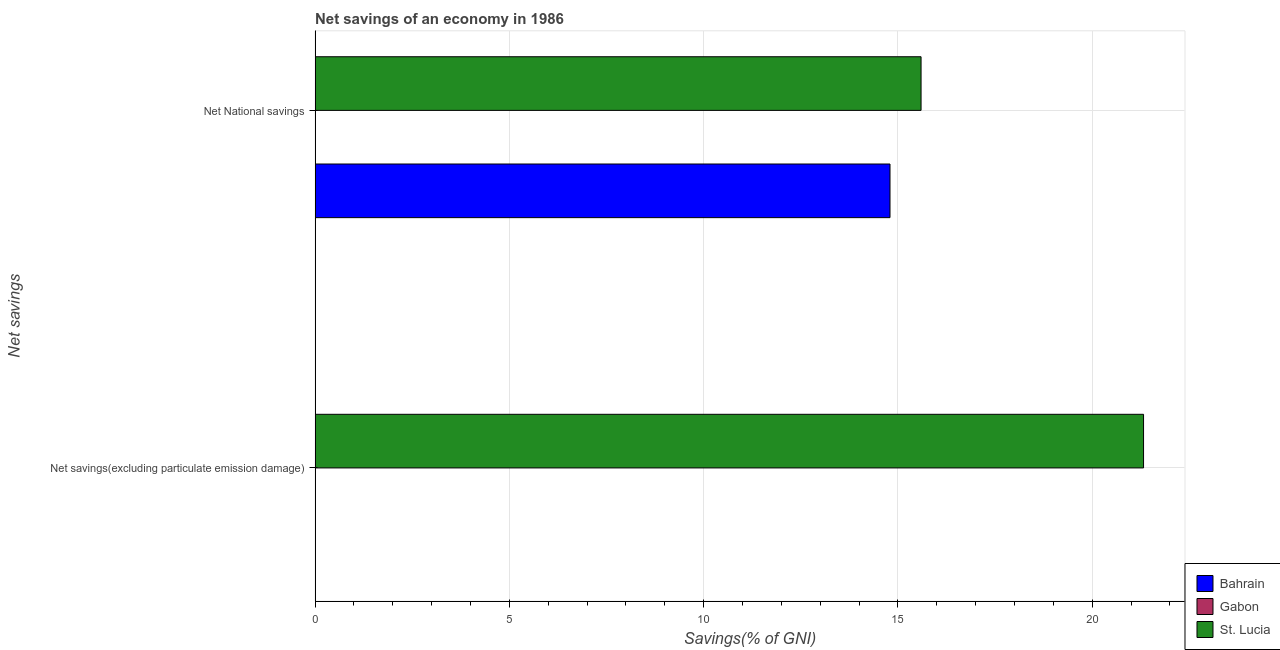How many different coloured bars are there?
Make the answer very short. 2. Are the number of bars per tick equal to the number of legend labels?
Provide a succinct answer. No. Are the number of bars on each tick of the Y-axis equal?
Give a very brief answer. No. What is the label of the 1st group of bars from the top?
Give a very brief answer. Net National savings. What is the net national savings in St. Lucia?
Your answer should be very brief. 15.59. Across all countries, what is the maximum net national savings?
Your response must be concise. 15.59. Across all countries, what is the minimum net savings(excluding particulate emission damage)?
Offer a terse response. 0. In which country was the net national savings maximum?
Make the answer very short. St. Lucia. What is the total net national savings in the graph?
Offer a terse response. 30.39. What is the difference between the net national savings in Bahrain and that in St. Lucia?
Ensure brevity in your answer.  -0.8. What is the difference between the net savings(excluding particulate emission damage) in St. Lucia and the net national savings in Gabon?
Give a very brief answer. 21.32. What is the average net savings(excluding particulate emission damage) per country?
Provide a succinct answer. 7.11. What is the difference between the net national savings and net savings(excluding particulate emission damage) in St. Lucia?
Give a very brief answer. -5.73. What is the ratio of the net national savings in Bahrain to that in St. Lucia?
Provide a short and direct response. 0.95. Are all the bars in the graph horizontal?
Offer a very short reply. Yes. What is the difference between two consecutive major ticks on the X-axis?
Ensure brevity in your answer.  5. Does the graph contain any zero values?
Provide a succinct answer. Yes. What is the title of the graph?
Your answer should be very brief. Net savings of an economy in 1986. What is the label or title of the X-axis?
Give a very brief answer. Savings(% of GNI). What is the label or title of the Y-axis?
Your answer should be very brief. Net savings. What is the Savings(% of GNI) of St. Lucia in Net savings(excluding particulate emission damage)?
Offer a terse response. 21.32. What is the Savings(% of GNI) of Bahrain in Net National savings?
Provide a succinct answer. 14.8. What is the Savings(% of GNI) in St. Lucia in Net National savings?
Offer a terse response. 15.59. Across all Net savings, what is the maximum Savings(% of GNI) in Bahrain?
Your answer should be compact. 14.8. Across all Net savings, what is the maximum Savings(% of GNI) of St. Lucia?
Keep it short and to the point. 21.32. Across all Net savings, what is the minimum Savings(% of GNI) in St. Lucia?
Provide a succinct answer. 15.59. What is the total Savings(% of GNI) of Bahrain in the graph?
Make the answer very short. 14.8. What is the total Savings(% of GNI) of Gabon in the graph?
Provide a short and direct response. 0. What is the total Savings(% of GNI) of St. Lucia in the graph?
Provide a short and direct response. 36.92. What is the difference between the Savings(% of GNI) of St. Lucia in Net savings(excluding particulate emission damage) and that in Net National savings?
Offer a very short reply. 5.73. What is the average Savings(% of GNI) of Bahrain per Net savings?
Give a very brief answer. 7.4. What is the average Savings(% of GNI) in St. Lucia per Net savings?
Ensure brevity in your answer.  18.46. What is the difference between the Savings(% of GNI) in Bahrain and Savings(% of GNI) in St. Lucia in Net National savings?
Your answer should be compact. -0.8. What is the ratio of the Savings(% of GNI) in St. Lucia in Net savings(excluding particulate emission damage) to that in Net National savings?
Ensure brevity in your answer.  1.37. What is the difference between the highest and the second highest Savings(% of GNI) in St. Lucia?
Make the answer very short. 5.73. What is the difference between the highest and the lowest Savings(% of GNI) in Bahrain?
Ensure brevity in your answer.  14.8. What is the difference between the highest and the lowest Savings(% of GNI) in St. Lucia?
Make the answer very short. 5.73. 